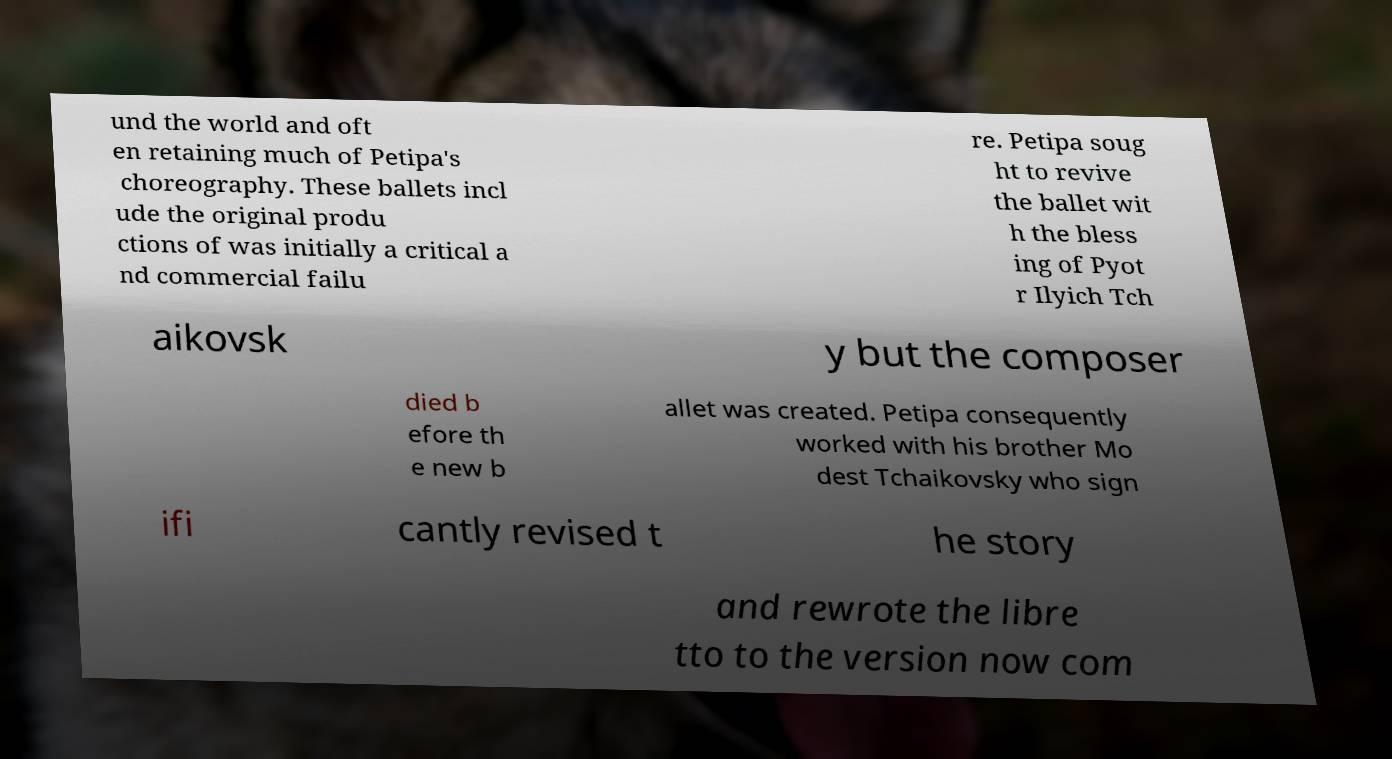There's text embedded in this image that I need extracted. Can you transcribe it verbatim? und the world and oft en retaining much of Petipa's choreography. These ballets incl ude the original produ ctions of was initially a critical a nd commercial failu re. Petipa soug ht to revive the ballet wit h the bless ing of Pyot r Ilyich Tch aikovsk y but the composer died b efore th e new b allet was created. Petipa consequently worked with his brother Mo dest Tchaikovsky who sign ifi cantly revised t he story and rewrote the libre tto to the version now com 